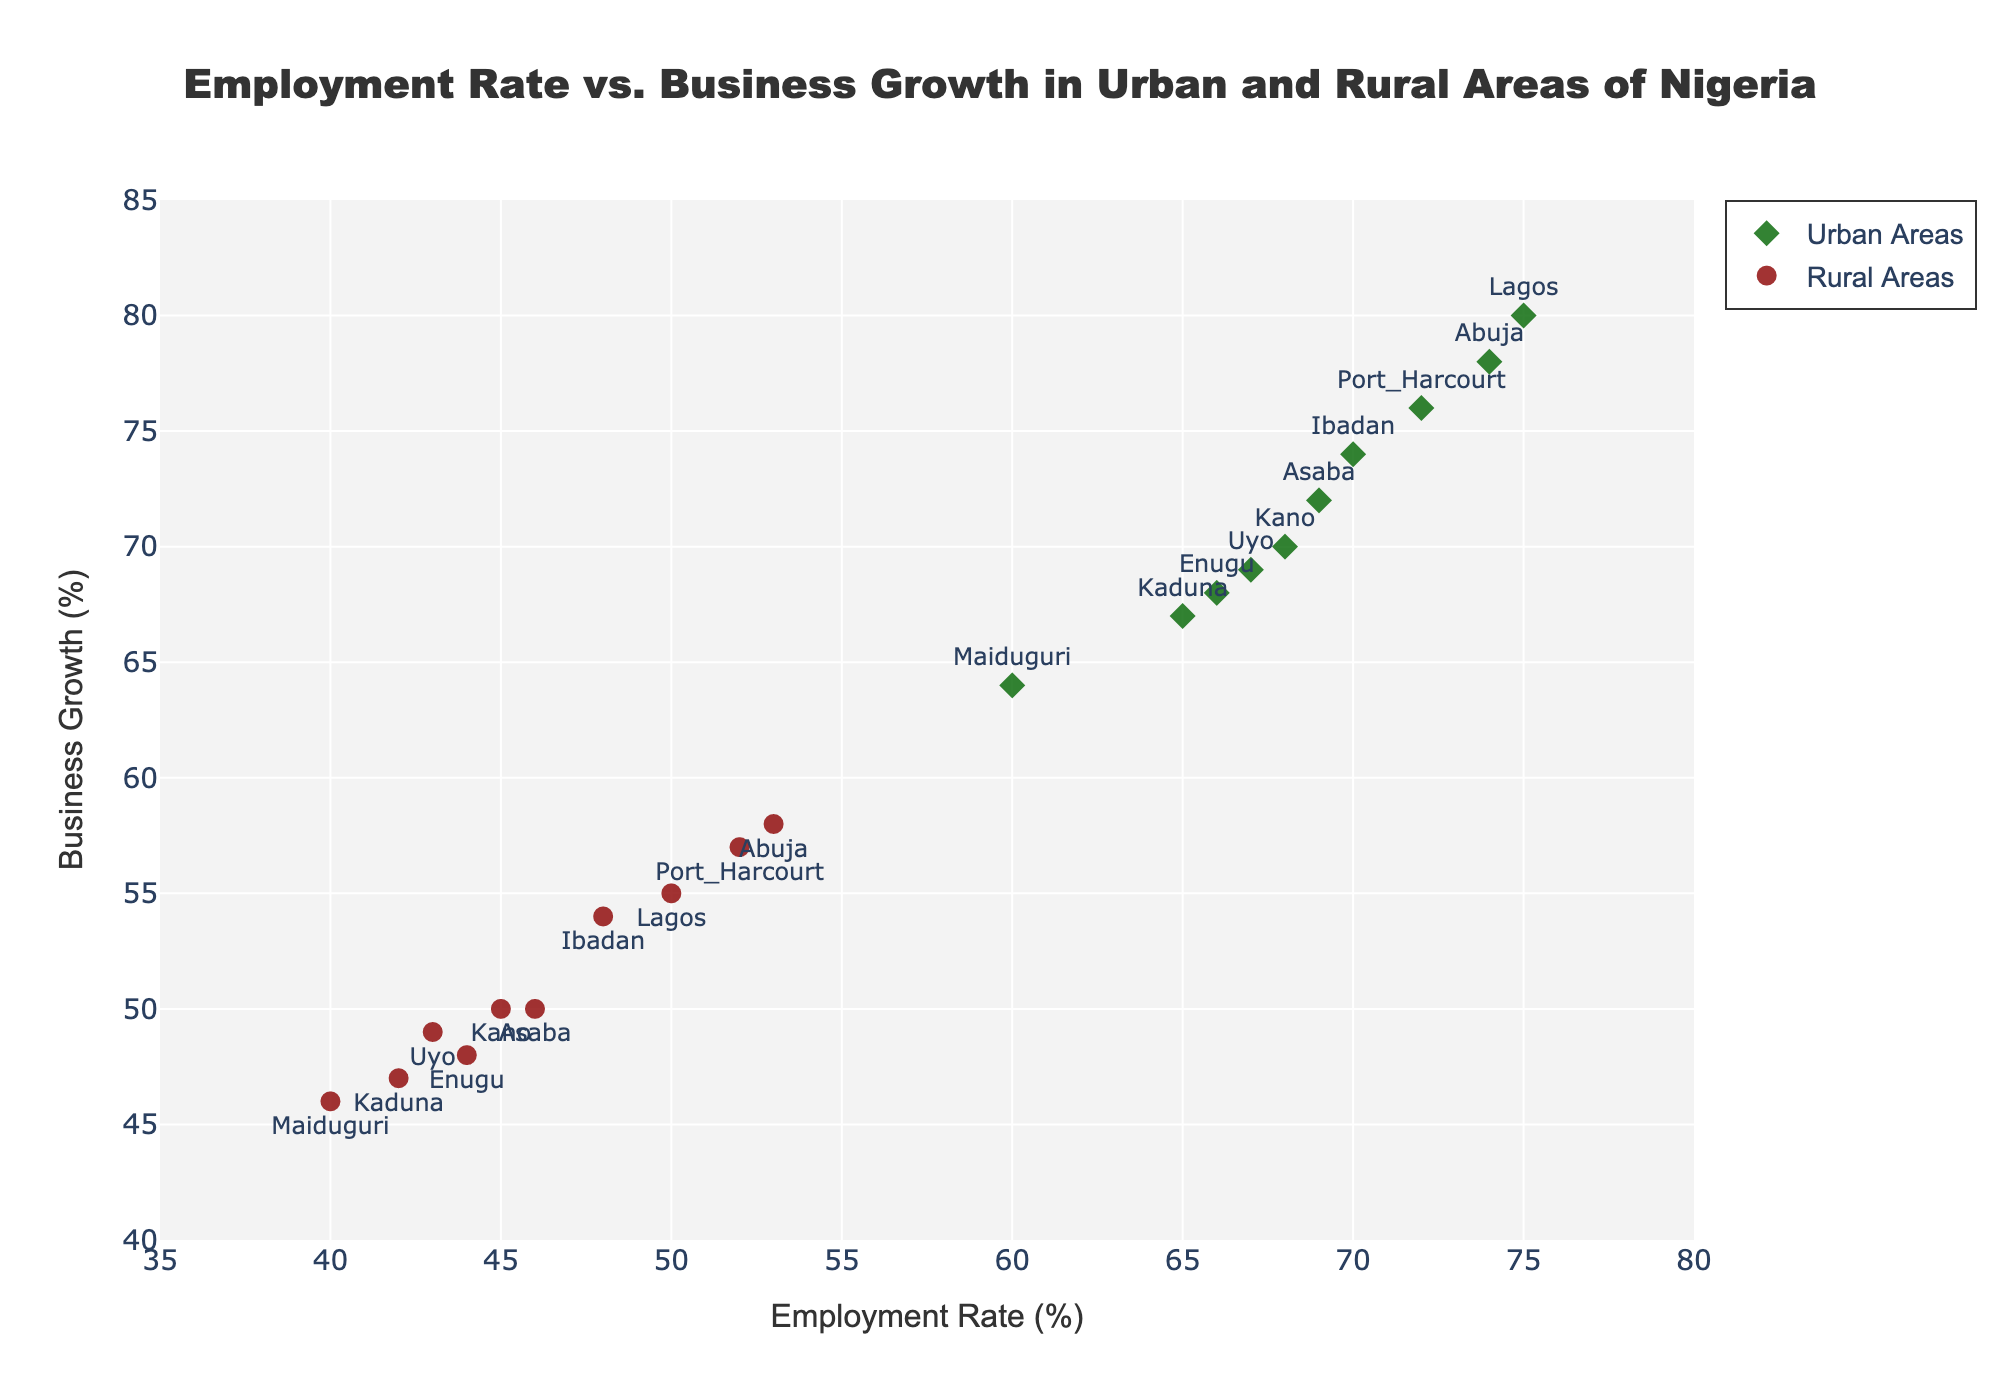What is the title of the plot? The title is displayed at the top of the plot. It provides an overview of what the plot represents.
Answer: "Employment Rate vs. Business Growth in Urban and Rural Areas of Nigeria" How many urban areas are represented in the plot? The urban areas are represented by diamonds with text labels. Counting these will give us the number of urban areas.
Answer: 10 Which area has the highest employment rate among rural areas? Locate the largest employment rate value among the rural areas (circles with text labels). The highest value is 53 for Abuja_Rural.
Answer: Abuja How do business growth rates in urban areas compare to rural areas? By comparing the y-values (Business Growth) of urban (diamonds) and rural (circles) areas, urban areas generally show higher business growth.
Answer: Urban areas generally have higher business growth What is the employment rate range for urban areas? Observe the employment rates for all urban areas (diamonds). The lowest is 60 (Maiduguri_Urban) and the highest is 75 (Lagos_Urban).
Answer: 60 to 75 Which urban area has the lowest business growth rate? Look for the minimum business growth value among urban areas. Enugu_Urban has the lowest at 68.
Answer: Enugu What is the average business growth rate for the rural areas? Add the business growth rates for all rural areas and divide by the number of areas: (55+50+57+58+54+48+47+46+49+50)/10.
Answer: 51.4 Is there any rural area that has a higher business growth rate than any urban area? Compare the highest business growth rate of rural areas (58 for Abuja_Rural) with the lowest of urban areas (68 for Enugu_Urban). None of the rural areas exceed this.
Answer: No Which area has the largest gap between employment rate and business growth rate among urban areas? Calculate the difference for each urban area and find the maximum gap: Lagos_Urban (75-80), Kano_Urban (68-70), Port_Harcourt_Urban (72-76), Abuja_Urban (74-78), Ibadan_Urban (70-74), Enugu_Urban (66-68), Kaduna_Urban (65-67), Maiduguri_Urban (60-64), Uyo_Urban (67-69), Asaba_Urban (69-72). The largest gap is Lagos_Urban with 5.
Answer: Lagos What type of contour coloring is used for urban areas? The urban areas are represented using the 'Viridis' colorscale as per the legend and the description in the plot.
Answer: Lines with 'Viridis' colorscale 